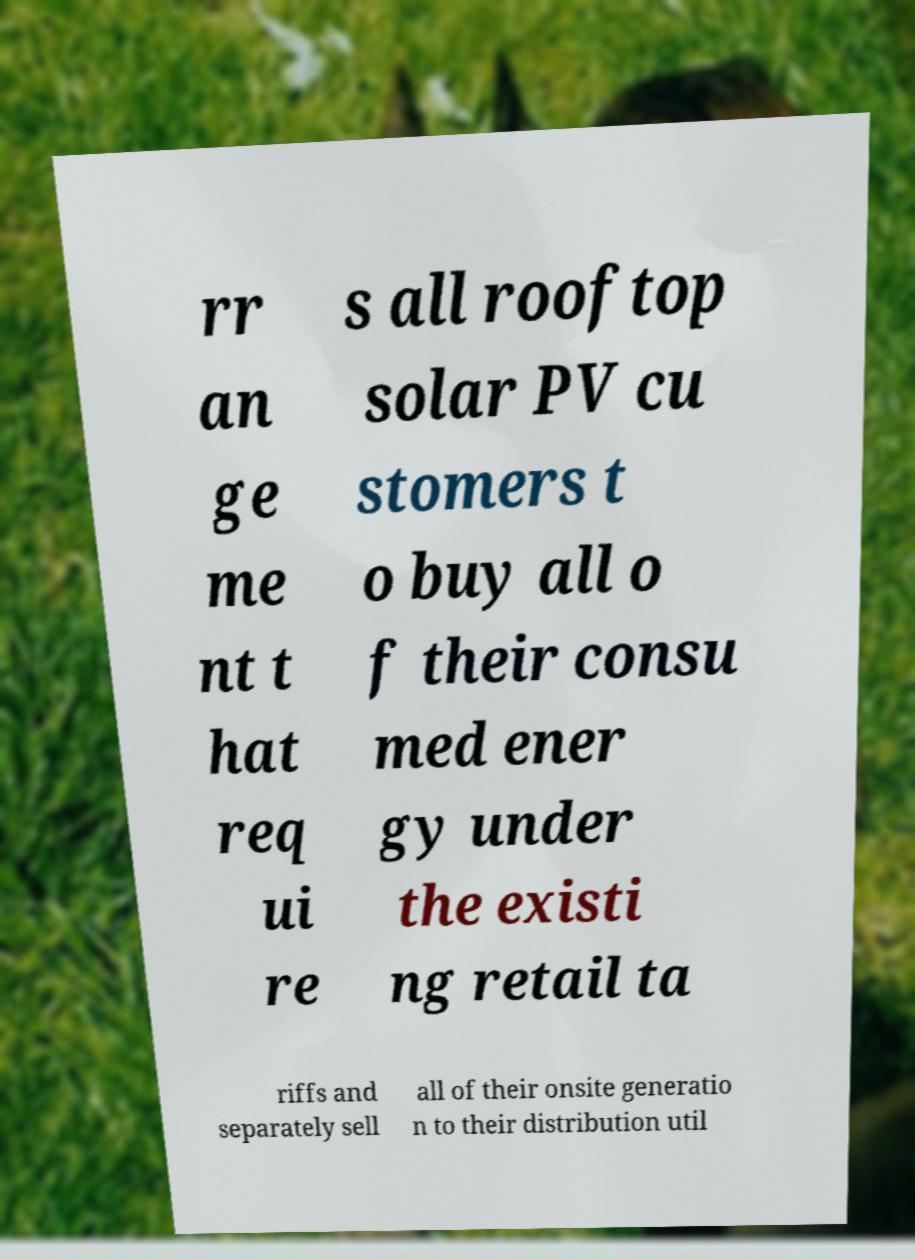Please identify and transcribe the text found in this image. rr an ge me nt t hat req ui re s all rooftop solar PV cu stomers t o buy all o f their consu med ener gy under the existi ng retail ta riffs and separately sell all of their onsite generatio n to their distribution util 